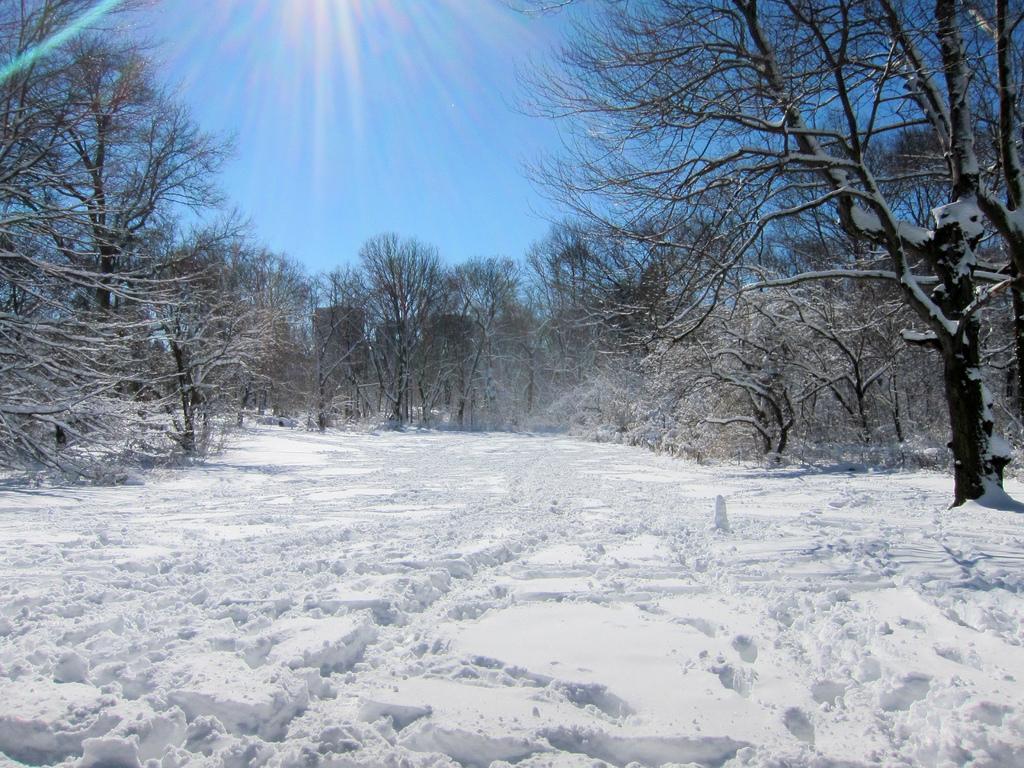In one or two sentences, can you explain what this image depicts? In this image there is a surface of the snow. In the background there are trees and the sky. 